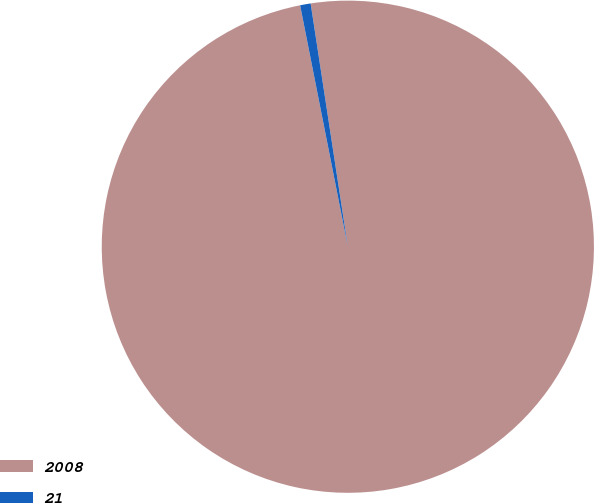Convert chart to OTSL. <chart><loc_0><loc_0><loc_500><loc_500><pie_chart><fcel>2008<fcel>21<nl><fcel>99.31%<fcel>0.69%<nl></chart> 